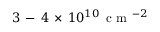Convert formula to latex. <formula><loc_0><loc_0><loc_500><loc_500>3 \, - \, 4 \, \times \, 1 0 ^ { 1 0 } \, c m ^ { - 2 }</formula> 